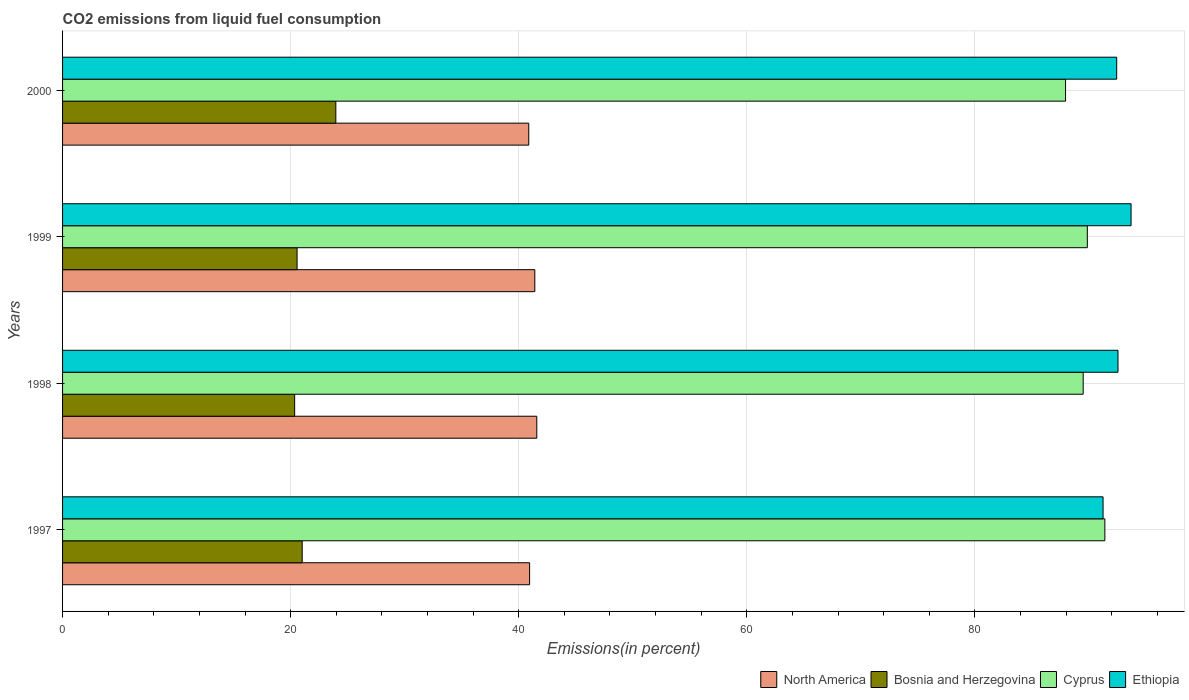How many bars are there on the 3rd tick from the bottom?
Give a very brief answer. 4. In how many cases, is the number of bars for a given year not equal to the number of legend labels?
Ensure brevity in your answer.  0. What is the total CO2 emitted in Bosnia and Herzegovina in 1998?
Keep it short and to the point. 20.35. Across all years, what is the maximum total CO2 emitted in Cyprus?
Your answer should be compact. 91.4. Across all years, what is the minimum total CO2 emitted in Ethiopia?
Your answer should be very brief. 91.24. In which year was the total CO2 emitted in Cyprus maximum?
Offer a terse response. 1997. In which year was the total CO2 emitted in Cyprus minimum?
Provide a succinct answer. 2000. What is the total total CO2 emitted in Bosnia and Herzegovina in the graph?
Keep it short and to the point. 85.89. What is the difference between the total CO2 emitted in Bosnia and Herzegovina in 1999 and that in 2000?
Provide a succinct answer. -3.4. What is the difference between the total CO2 emitted in Ethiopia in 2000 and the total CO2 emitted in Bosnia and Herzegovina in 1999?
Provide a short and direct response. 71.87. What is the average total CO2 emitted in Ethiopia per year?
Ensure brevity in your answer.  92.48. In the year 2000, what is the difference between the total CO2 emitted in Bosnia and Herzegovina and total CO2 emitted in North America?
Ensure brevity in your answer.  -16.92. What is the ratio of the total CO2 emitted in Cyprus in 1998 to that in 2000?
Keep it short and to the point. 1.02. Is the difference between the total CO2 emitted in Bosnia and Herzegovina in 1998 and 2000 greater than the difference between the total CO2 emitted in North America in 1998 and 2000?
Your answer should be very brief. No. What is the difference between the highest and the second highest total CO2 emitted in Cyprus?
Make the answer very short. 1.54. What is the difference between the highest and the lowest total CO2 emitted in Cyprus?
Provide a short and direct response. 3.45. In how many years, is the total CO2 emitted in North America greater than the average total CO2 emitted in North America taken over all years?
Make the answer very short. 2. What does the 3rd bar from the top in 2000 represents?
Provide a short and direct response. Bosnia and Herzegovina. What does the 1st bar from the bottom in 2000 represents?
Ensure brevity in your answer.  North America. Does the graph contain grids?
Your answer should be compact. Yes. Where does the legend appear in the graph?
Your answer should be very brief. Bottom right. What is the title of the graph?
Offer a very short reply. CO2 emissions from liquid fuel consumption. Does "North America" appear as one of the legend labels in the graph?
Provide a succinct answer. Yes. What is the label or title of the X-axis?
Make the answer very short. Emissions(in percent). What is the Emissions(in percent) in North America in 1997?
Make the answer very short. 40.96. What is the Emissions(in percent) of Bosnia and Herzegovina in 1997?
Provide a short and direct response. 21.01. What is the Emissions(in percent) in Cyprus in 1997?
Your answer should be very brief. 91.4. What is the Emissions(in percent) of Ethiopia in 1997?
Provide a short and direct response. 91.24. What is the Emissions(in percent) of North America in 1998?
Your response must be concise. 41.59. What is the Emissions(in percent) of Bosnia and Herzegovina in 1998?
Offer a very short reply. 20.35. What is the Emissions(in percent) of Cyprus in 1998?
Provide a succinct answer. 89.5. What is the Emissions(in percent) of Ethiopia in 1998?
Give a very brief answer. 92.55. What is the Emissions(in percent) of North America in 1999?
Your answer should be very brief. 41.41. What is the Emissions(in percent) of Bosnia and Herzegovina in 1999?
Keep it short and to the point. 20.57. What is the Emissions(in percent) of Cyprus in 1999?
Offer a very short reply. 89.86. What is the Emissions(in percent) of Ethiopia in 1999?
Give a very brief answer. 93.7. What is the Emissions(in percent) in North America in 2000?
Offer a very short reply. 40.88. What is the Emissions(in percent) in Bosnia and Herzegovina in 2000?
Keep it short and to the point. 23.96. What is the Emissions(in percent) in Cyprus in 2000?
Ensure brevity in your answer.  87.96. What is the Emissions(in percent) of Ethiopia in 2000?
Keep it short and to the point. 92.44. Across all years, what is the maximum Emissions(in percent) in North America?
Your answer should be compact. 41.59. Across all years, what is the maximum Emissions(in percent) of Bosnia and Herzegovina?
Ensure brevity in your answer.  23.96. Across all years, what is the maximum Emissions(in percent) of Cyprus?
Make the answer very short. 91.4. Across all years, what is the maximum Emissions(in percent) in Ethiopia?
Make the answer very short. 93.7. Across all years, what is the minimum Emissions(in percent) of North America?
Provide a short and direct response. 40.88. Across all years, what is the minimum Emissions(in percent) in Bosnia and Herzegovina?
Your response must be concise. 20.35. Across all years, what is the minimum Emissions(in percent) of Cyprus?
Ensure brevity in your answer.  87.96. Across all years, what is the minimum Emissions(in percent) in Ethiopia?
Give a very brief answer. 91.24. What is the total Emissions(in percent) of North America in the graph?
Offer a terse response. 164.84. What is the total Emissions(in percent) in Bosnia and Herzegovina in the graph?
Keep it short and to the point. 85.89. What is the total Emissions(in percent) in Cyprus in the graph?
Provide a short and direct response. 358.72. What is the total Emissions(in percent) of Ethiopia in the graph?
Your response must be concise. 369.94. What is the difference between the Emissions(in percent) of North America in 1997 and that in 1998?
Keep it short and to the point. -0.63. What is the difference between the Emissions(in percent) in Bosnia and Herzegovina in 1997 and that in 1998?
Offer a very short reply. 0.66. What is the difference between the Emissions(in percent) of Cyprus in 1997 and that in 1998?
Make the answer very short. 1.9. What is the difference between the Emissions(in percent) of Ethiopia in 1997 and that in 1998?
Your response must be concise. -1.31. What is the difference between the Emissions(in percent) in North America in 1997 and that in 1999?
Your answer should be very brief. -0.46. What is the difference between the Emissions(in percent) in Bosnia and Herzegovina in 1997 and that in 1999?
Give a very brief answer. 0.45. What is the difference between the Emissions(in percent) of Cyprus in 1997 and that in 1999?
Your answer should be compact. 1.54. What is the difference between the Emissions(in percent) of Ethiopia in 1997 and that in 1999?
Give a very brief answer. -2.46. What is the difference between the Emissions(in percent) in North America in 1997 and that in 2000?
Your answer should be very brief. 0.08. What is the difference between the Emissions(in percent) of Bosnia and Herzegovina in 1997 and that in 2000?
Ensure brevity in your answer.  -2.95. What is the difference between the Emissions(in percent) in Cyprus in 1997 and that in 2000?
Provide a short and direct response. 3.45. What is the difference between the Emissions(in percent) of Ethiopia in 1997 and that in 2000?
Keep it short and to the point. -1.19. What is the difference between the Emissions(in percent) in North America in 1998 and that in 1999?
Your response must be concise. 0.17. What is the difference between the Emissions(in percent) in Bosnia and Herzegovina in 1998 and that in 1999?
Offer a very short reply. -0.21. What is the difference between the Emissions(in percent) in Cyprus in 1998 and that in 1999?
Your answer should be very brief. -0.36. What is the difference between the Emissions(in percent) of Ethiopia in 1998 and that in 1999?
Ensure brevity in your answer.  -1.15. What is the difference between the Emissions(in percent) of North America in 1998 and that in 2000?
Ensure brevity in your answer.  0.7. What is the difference between the Emissions(in percent) of Bosnia and Herzegovina in 1998 and that in 2000?
Offer a terse response. -3.61. What is the difference between the Emissions(in percent) of Cyprus in 1998 and that in 2000?
Give a very brief answer. 1.55. What is the difference between the Emissions(in percent) in Ethiopia in 1998 and that in 2000?
Your answer should be very brief. 0.12. What is the difference between the Emissions(in percent) of North America in 1999 and that in 2000?
Give a very brief answer. 0.53. What is the difference between the Emissions(in percent) of Bosnia and Herzegovina in 1999 and that in 2000?
Provide a short and direct response. -3.4. What is the difference between the Emissions(in percent) of Cyprus in 1999 and that in 2000?
Ensure brevity in your answer.  1.91. What is the difference between the Emissions(in percent) of Ethiopia in 1999 and that in 2000?
Offer a terse response. 1.26. What is the difference between the Emissions(in percent) in North America in 1997 and the Emissions(in percent) in Bosnia and Herzegovina in 1998?
Your answer should be compact. 20.6. What is the difference between the Emissions(in percent) in North America in 1997 and the Emissions(in percent) in Cyprus in 1998?
Provide a short and direct response. -48.54. What is the difference between the Emissions(in percent) of North America in 1997 and the Emissions(in percent) of Ethiopia in 1998?
Ensure brevity in your answer.  -51.6. What is the difference between the Emissions(in percent) of Bosnia and Herzegovina in 1997 and the Emissions(in percent) of Cyprus in 1998?
Make the answer very short. -68.49. What is the difference between the Emissions(in percent) of Bosnia and Herzegovina in 1997 and the Emissions(in percent) of Ethiopia in 1998?
Provide a succinct answer. -71.54. What is the difference between the Emissions(in percent) of Cyprus in 1997 and the Emissions(in percent) of Ethiopia in 1998?
Your response must be concise. -1.15. What is the difference between the Emissions(in percent) of North America in 1997 and the Emissions(in percent) of Bosnia and Herzegovina in 1999?
Ensure brevity in your answer.  20.39. What is the difference between the Emissions(in percent) of North America in 1997 and the Emissions(in percent) of Cyprus in 1999?
Offer a terse response. -48.91. What is the difference between the Emissions(in percent) in North America in 1997 and the Emissions(in percent) in Ethiopia in 1999?
Make the answer very short. -52.74. What is the difference between the Emissions(in percent) in Bosnia and Herzegovina in 1997 and the Emissions(in percent) in Cyprus in 1999?
Offer a very short reply. -68.85. What is the difference between the Emissions(in percent) of Bosnia and Herzegovina in 1997 and the Emissions(in percent) of Ethiopia in 1999?
Keep it short and to the point. -72.69. What is the difference between the Emissions(in percent) in Cyprus in 1997 and the Emissions(in percent) in Ethiopia in 1999?
Provide a succinct answer. -2.3. What is the difference between the Emissions(in percent) of North America in 1997 and the Emissions(in percent) of Bosnia and Herzegovina in 2000?
Your response must be concise. 16.99. What is the difference between the Emissions(in percent) in North America in 1997 and the Emissions(in percent) in Cyprus in 2000?
Provide a succinct answer. -47. What is the difference between the Emissions(in percent) of North America in 1997 and the Emissions(in percent) of Ethiopia in 2000?
Provide a succinct answer. -51.48. What is the difference between the Emissions(in percent) of Bosnia and Herzegovina in 1997 and the Emissions(in percent) of Cyprus in 2000?
Your answer should be very brief. -66.94. What is the difference between the Emissions(in percent) in Bosnia and Herzegovina in 1997 and the Emissions(in percent) in Ethiopia in 2000?
Your answer should be very brief. -71.42. What is the difference between the Emissions(in percent) in Cyprus in 1997 and the Emissions(in percent) in Ethiopia in 2000?
Provide a succinct answer. -1.04. What is the difference between the Emissions(in percent) in North America in 1998 and the Emissions(in percent) in Bosnia and Herzegovina in 1999?
Your answer should be compact. 21.02. What is the difference between the Emissions(in percent) of North America in 1998 and the Emissions(in percent) of Cyprus in 1999?
Give a very brief answer. -48.28. What is the difference between the Emissions(in percent) of North America in 1998 and the Emissions(in percent) of Ethiopia in 1999?
Your answer should be compact. -52.11. What is the difference between the Emissions(in percent) in Bosnia and Herzegovina in 1998 and the Emissions(in percent) in Cyprus in 1999?
Give a very brief answer. -69.51. What is the difference between the Emissions(in percent) in Bosnia and Herzegovina in 1998 and the Emissions(in percent) in Ethiopia in 1999?
Provide a succinct answer. -73.35. What is the difference between the Emissions(in percent) in Cyprus in 1998 and the Emissions(in percent) in Ethiopia in 1999?
Give a very brief answer. -4.2. What is the difference between the Emissions(in percent) in North America in 1998 and the Emissions(in percent) in Bosnia and Herzegovina in 2000?
Provide a succinct answer. 17.62. What is the difference between the Emissions(in percent) in North America in 1998 and the Emissions(in percent) in Cyprus in 2000?
Your response must be concise. -46.37. What is the difference between the Emissions(in percent) in North America in 1998 and the Emissions(in percent) in Ethiopia in 2000?
Make the answer very short. -50.85. What is the difference between the Emissions(in percent) in Bosnia and Herzegovina in 1998 and the Emissions(in percent) in Cyprus in 2000?
Offer a terse response. -67.6. What is the difference between the Emissions(in percent) in Bosnia and Herzegovina in 1998 and the Emissions(in percent) in Ethiopia in 2000?
Your answer should be very brief. -72.09. What is the difference between the Emissions(in percent) in Cyprus in 1998 and the Emissions(in percent) in Ethiopia in 2000?
Make the answer very short. -2.94. What is the difference between the Emissions(in percent) of North America in 1999 and the Emissions(in percent) of Bosnia and Herzegovina in 2000?
Your answer should be very brief. 17.45. What is the difference between the Emissions(in percent) of North America in 1999 and the Emissions(in percent) of Cyprus in 2000?
Make the answer very short. -46.54. What is the difference between the Emissions(in percent) of North America in 1999 and the Emissions(in percent) of Ethiopia in 2000?
Provide a short and direct response. -51.03. What is the difference between the Emissions(in percent) of Bosnia and Herzegovina in 1999 and the Emissions(in percent) of Cyprus in 2000?
Offer a very short reply. -67.39. What is the difference between the Emissions(in percent) in Bosnia and Herzegovina in 1999 and the Emissions(in percent) in Ethiopia in 2000?
Your answer should be compact. -71.87. What is the difference between the Emissions(in percent) in Cyprus in 1999 and the Emissions(in percent) in Ethiopia in 2000?
Provide a succinct answer. -2.57. What is the average Emissions(in percent) in North America per year?
Give a very brief answer. 41.21. What is the average Emissions(in percent) of Bosnia and Herzegovina per year?
Offer a very short reply. 21.47. What is the average Emissions(in percent) in Cyprus per year?
Make the answer very short. 89.68. What is the average Emissions(in percent) in Ethiopia per year?
Give a very brief answer. 92.48. In the year 1997, what is the difference between the Emissions(in percent) in North America and Emissions(in percent) in Bosnia and Herzegovina?
Your answer should be very brief. 19.94. In the year 1997, what is the difference between the Emissions(in percent) in North America and Emissions(in percent) in Cyprus?
Give a very brief answer. -50.44. In the year 1997, what is the difference between the Emissions(in percent) of North America and Emissions(in percent) of Ethiopia?
Make the answer very short. -50.29. In the year 1997, what is the difference between the Emissions(in percent) in Bosnia and Herzegovina and Emissions(in percent) in Cyprus?
Your answer should be very brief. -70.39. In the year 1997, what is the difference between the Emissions(in percent) of Bosnia and Herzegovina and Emissions(in percent) of Ethiopia?
Keep it short and to the point. -70.23. In the year 1997, what is the difference between the Emissions(in percent) in Cyprus and Emissions(in percent) in Ethiopia?
Make the answer very short. 0.16. In the year 1998, what is the difference between the Emissions(in percent) of North America and Emissions(in percent) of Bosnia and Herzegovina?
Offer a terse response. 21.23. In the year 1998, what is the difference between the Emissions(in percent) of North America and Emissions(in percent) of Cyprus?
Your response must be concise. -47.91. In the year 1998, what is the difference between the Emissions(in percent) in North America and Emissions(in percent) in Ethiopia?
Make the answer very short. -50.97. In the year 1998, what is the difference between the Emissions(in percent) in Bosnia and Herzegovina and Emissions(in percent) in Cyprus?
Keep it short and to the point. -69.15. In the year 1998, what is the difference between the Emissions(in percent) in Bosnia and Herzegovina and Emissions(in percent) in Ethiopia?
Keep it short and to the point. -72.2. In the year 1998, what is the difference between the Emissions(in percent) in Cyprus and Emissions(in percent) in Ethiopia?
Give a very brief answer. -3.05. In the year 1999, what is the difference between the Emissions(in percent) of North America and Emissions(in percent) of Bosnia and Herzegovina?
Ensure brevity in your answer.  20.85. In the year 1999, what is the difference between the Emissions(in percent) in North America and Emissions(in percent) in Cyprus?
Offer a terse response. -48.45. In the year 1999, what is the difference between the Emissions(in percent) of North America and Emissions(in percent) of Ethiopia?
Your answer should be very brief. -52.29. In the year 1999, what is the difference between the Emissions(in percent) in Bosnia and Herzegovina and Emissions(in percent) in Cyprus?
Your answer should be compact. -69.3. In the year 1999, what is the difference between the Emissions(in percent) in Bosnia and Herzegovina and Emissions(in percent) in Ethiopia?
Offer a terse response. -73.13. In the year 1999, what is the difference between the Emissions(in percent) in Cyprus and Emissions(in percent) in Ethiopia?
Keep it short and to the point. -3.84. In the year 2000, what is the difference between the Emissions(in percent) of North America and Emissions(in percent) of Bosnia and Herzegovina?
Provide a succinct answer. 16.92. In the year 2000, what is the difference between the Emissions(in percent) of North America and Emissions(in percent) of Cyprus?
Make the answer very short. -47.07. In the year 2000, what is the difference between the Emissions(in percent) of North America and Emissions(in percent) of Ethiopia?
Your answer should be compact. -51.56. In the year 2000, what is the difference between the Emissions(in percent) of Bosnia and Herzegovina and Emissions(in percent) of Cyprus?
Provide a succinct answer. -63.99. In the year 2000, what is the difference between the Emissions(in percent) in Bosnia and Herzegovina and Emissions(in percent) in Ethiopia?
Ensure brevity in your answer.  -68.48. In the year 2000, what is the difference between the Emissions(in percent) of Cyprus and Emissions(in percent) of Ethiopia?
Your response must be concise. -4.48. What is the ratio of the Emissions(in percent) of North America in 1997 to that in 1998?
Make the answer very short. 0.98. What is the ratio of the Emissions(in percent) in Bosnia and Herzegovina in 1997 to that in 1998?
Your response must be concise. 1.03. What is the ratio of the Emissions(in percent) of Cyprus in 1997 to that in 1998?
Provide a short and direct response. 1.02. What is the ratio of the Emissions(in percent) of Ethiopia in 1997 to that in 1998?
Ensure brevity in your answer.  0.99. What is the ratio of the Emissions(in percent) in Bosnia and Herzegovina in 1997 to that in 1999?
Offer a terse response. 1.02. What is the ratio of the Emissions(in percent) in Cyprus in 1997 to that in 1999?
Give a very brief answer. 1.02. What is the ratio of the Emissions(in percent) of Ethiopia in 1997 to that in 1999?
Provide a short and direct response. 0.97. What is the ratio of the Emissions(in percent) in Bosnia and Herzegovina in 1997 to that in 2000?
Your response must be concise. 0.88. What is the ratio of the Emissions(in percent) of Cyprus in 1997 to that in 2000?
Keep it short and to the point. 1.04. What is the ratio of the Emissions(in percent) in Ethiopia in 1997 to that in 2000?
Offer a very short reply. 0.99. What is the ratio of the Emissions(in percent) in North America in 1998 to that in 1999?
Provide a short and direct response. 1. What is the ratio of the Emissions(in percent) in Bosnia and Herzegovina in 1998 to that in 1999?
Give a very brief answer. 0.99. What is the ratio of the Emissions(in percent) of Cyprus in 1998 to that in 1999?
Offer a terse response. 1. What is the ratio of the Emissions(in percent) of Ethiopia in 1998 to that in 1999?
Give a very brief answer. 0.99. What is the ratio of the Emissions(in percent) of North America in 1998 to that in 2000?
Ensure brevity in your answer.  1.02. What is the ratio of the Emissions(in percent) of Bosnia and Herzegovina in 1998 to that in 2000?
Your answer should be compact. 0.85. What is the ratio of the Emissions(in percent) in Cyprus in 1998 to that in 2000?
Make the answer very short. 1.02. What is the ratio of the Emissions(in percent) of Bosnia and Herzegovina in 1999 to that in 2000?
Give a very brief answer. 0.86. What is the ratio of the Emissions(in percent) in Cyprus in 1999 to that in 2000?
Ensure brevity in your answer.  1.02. What is the ratio of the Emissions(in percent) in Ethiopia in 1999 to that in 2000?
Your answer should be very brief. 1.01. What is the difference between the highest and the second highest Emissions(in percent) in North America?
Offer a terse response. 0.17. What is the difference between the highest and the second highest Emissions(in percent) of Bosnia and Herzegovina?
Offer a very short reply. 2.95. What is the difference between the highest and the second highest Emissions(in percent) of Cyprus?
Your answer should be very brief. 1.54. What is the difference between the highest and the second highest Emissions(in percent) in Ethiopia?
Keep it short and to the point. 1.15. What is the difference between the highest and the lowest Emissions(in percent) in North America?
Provide a succinct answer. 0.7. What is the difference between the highest and the lowest Emissions(in percent) of Bosnia and Herzegovina?
Offer a terse response. 3.61. What is the difference between the highest and the lowest Emissions(in percent) in Cyprus?
Offer a terse response. 3.45. What is the difference between the highest and the lowest Emissions(in percent) of Ethiopia?
Make the answer very short. 2.46. 